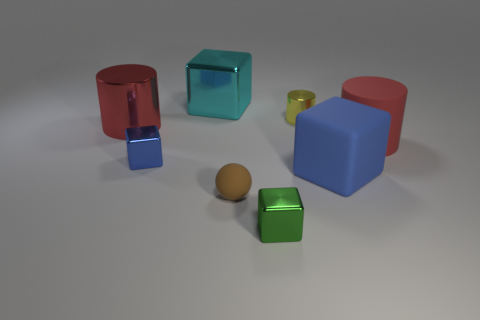Subtract all metallic cylinders. How many cylinders are left? 1 Add 2 blue blocks. How many objects exist? 10 Subtract 3 blocks. How many blocks are left? 1 Subtract all red cylinders. How many cylinders are left? 1 Subtract all spheres. How many objects are left? 7 Subtract all purple cylinders. Subtract all blue blocks. How many cylinders are left? 3 Subtract all brown balls. How many cyan cubes are left? 1 Subtract all brown rubber spheres. Subtract all small yellow metallic things. How many objects are left? 6 Add 4 cyan metal cubes. How many cyan metal cubes are left? 5 Add 1 large shiny things. How many large shiny things exist? 3 